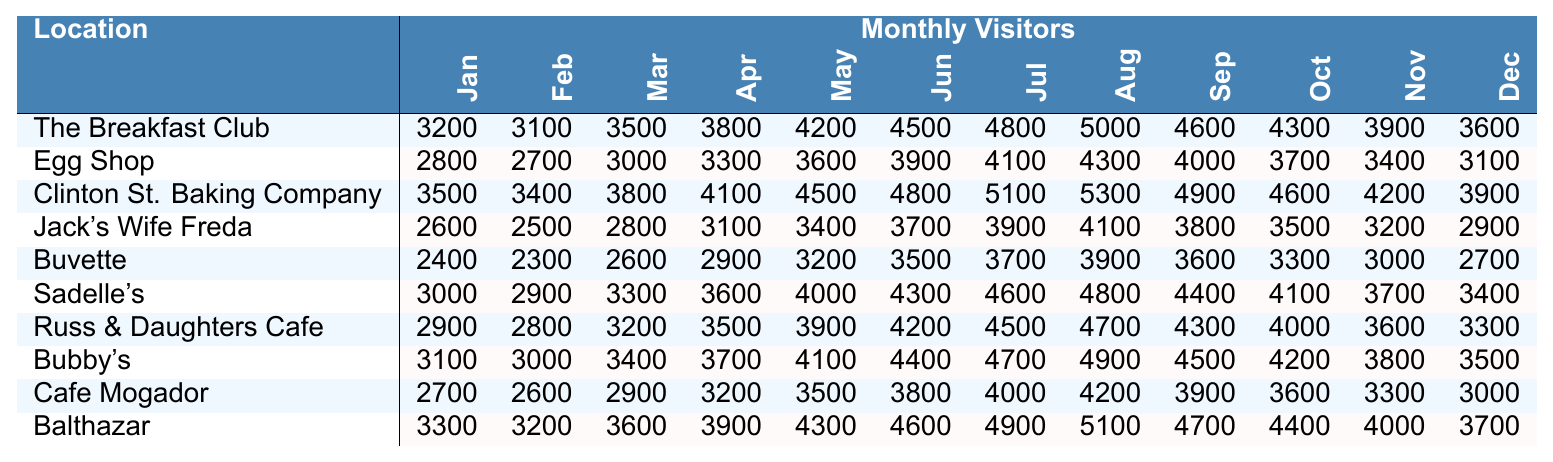What location had the highest number of visitors in June? By looking at the June visitor data in the table, the highest value is 5100 from Clinton St. Baking Company.
Answer: Clinton St. Baking Company What was the total number of visitors to The Breakfast Club for the first half of the year (January to June)? The visitors for The Breakfast Club from January to June are: 3200 + 3100 + 3500 + 3800 + 4200 + 4500. Summing these values gives: 3200 + 3100 + 3500 + 3800 + 4200 + 4500 = 22300.
Answer: 22300 Which location saw an increase in visitors from May to June? Comparing the visitors from May to June for each location, The Breakfast Club (4200 to 4500), Clinton St. Baking Company (4500 to 4800), Sadelle's (4000 to 4300), and Russ & Daughters Cafe (3900 to 4200) all saw an increase.
Answer: The Breakfast Club, Clinton St. Baking Company, Sadelle's, Russ & Daughters Cafe What is the average number of visitors for Egg Shop throughout the year? To find the average, add the monthly visitors for Egg Shop (2800 + 2700 + 3000 + 3300 + 3600 + 3900 + 4100 + 4300 + 4000 + 3700 + 3400 + 3100 = 43300) and divide by 12 (43300 / 12 ≈ 3608.33, rounded to 3608).
Answer: 3608 Which two locations had the fewest visitors in December? Looking at the data for December, Buvette has 2700 and Jack's Wife Freda has 2900. These are the two lowest values for December.
Answer: Buvette and Jack's Wife Freda What percentage increase in visitors did Balthazar experience from May to June? The number of visitors for Balthazar in May is 4300 and in June is 4600. The increase is (4600 - 4300) = 300. The percentage increase is (300 / 4300) * 100 ≈ 6.98%.
Answer: Approximately 6.98% Did Cafe Mogador have more visitors in the first half of the year than in the second half? In the first half (January to June), Cafe Mogador had a total of 2700 + 2600 + 2900 + 3200 + 3500 + 3800 = 18600 visitors. In the second half (July to December), it had 4000 + 4200 + 3900 + 3600 + 3300 + 3000 = 22000. Since 22000 is greater than 18600, Cafe Mogador had more visitors in the second half.
Answer: No What is the median number of visitors for all locations in October? First, find the number of visitors in October for each location: 4300, 3700, 4600, 3500, 3300, 4100, 4000, 4200, 3600, 4400. Ordering these values: 3500, 3600, 3700, 4000, 4100, 4200, 4300, 4400, 4600. The median is the average of the 5th and 6th values (4100 + 4200)/2 = 4150.
Answer: 4150 Which location had the most consistent visitor numbers across all months? Consistency can be gauged by observing the ranges of visitors. The location with the smallest difference between the maximum and minimum visitor counts is Egg Shop (2800 to 4300, a difference of 1500).
Answer: Egg Shop What is the comparison of total visitors for Bubby's versus Sadelle's for the entire year? Bubby's total is 3100 + 3000 + 3400 + 3700 + 4100 + 4400 + 4700 + 4900 + 4500 + 4200 + 3800 + 3500 = 50000. Sadelle's total is 3000 + 2900 + 3300 + 3600 + 4000 + 4300 + 4600 + 4800 + 4400 + 4100 + 3700 + 3400 = 50000. Both have the same total, 50000.
Answer: They are equal 